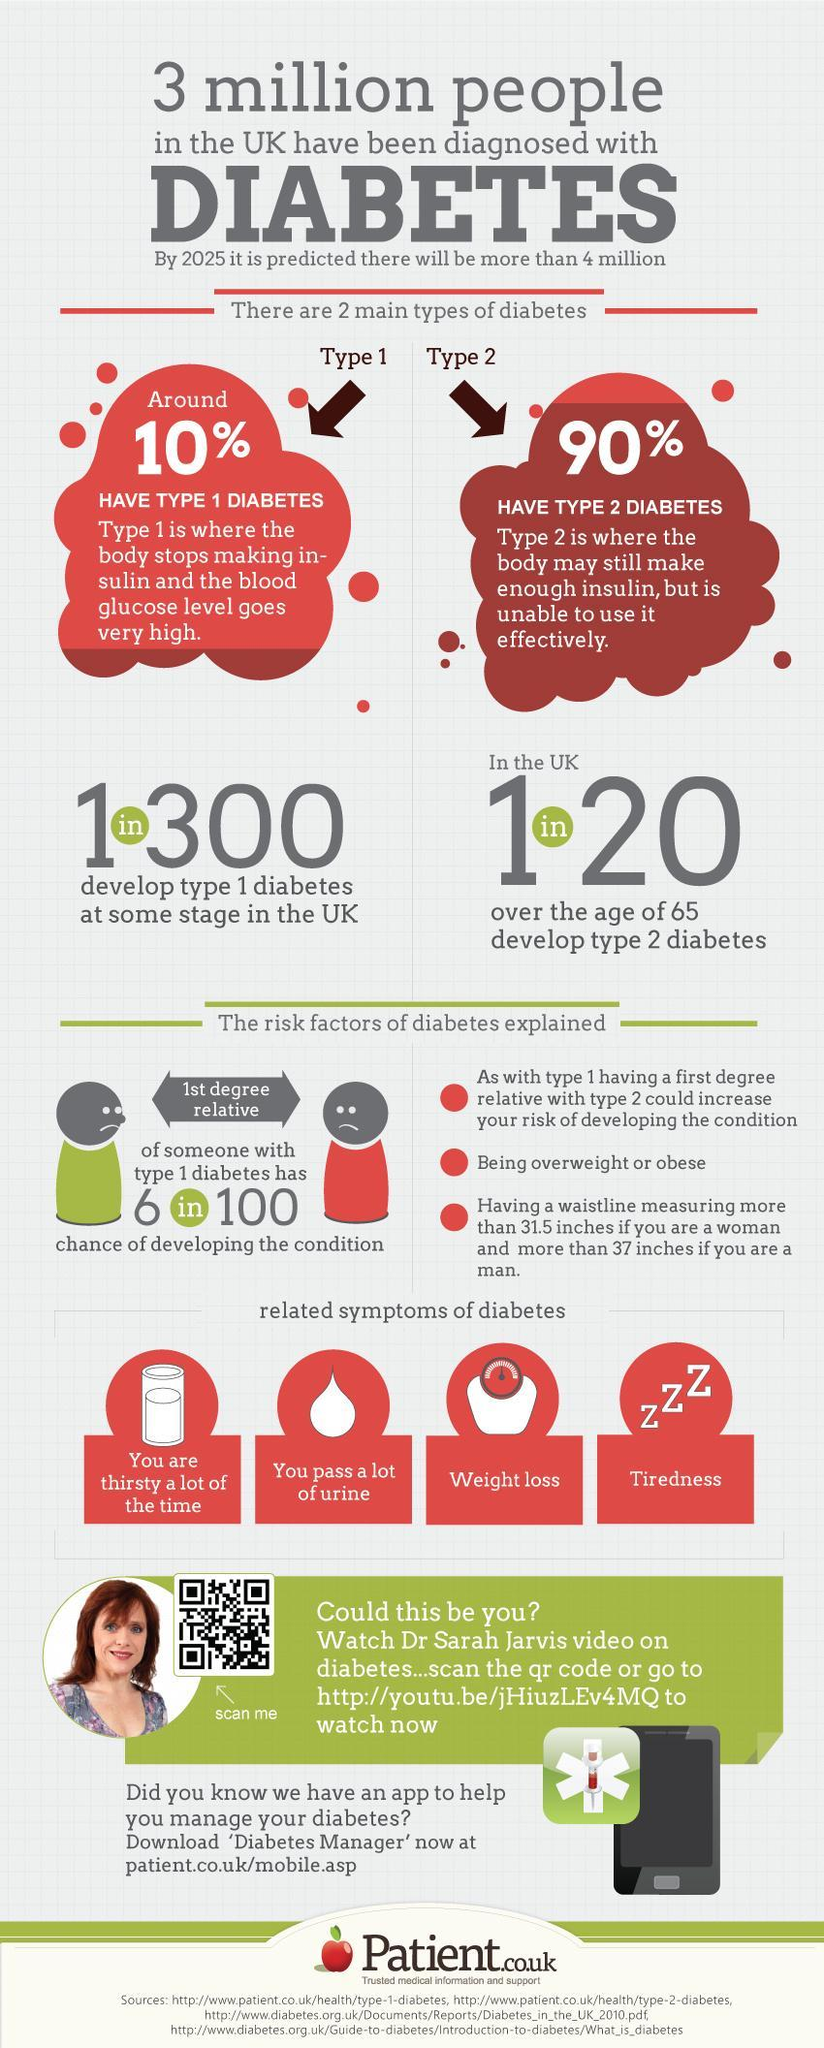Which type of diabetes is more common among the senior citizens?
Answer the question with a short phrase. type 2 diabetes Which type of diabetes does not have an age limit and can occur any time? type 1 diabetes 